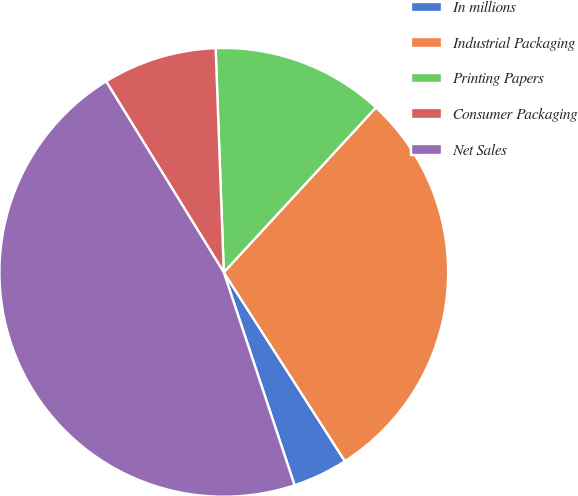<chart> <loc_0><loc_0><loc_500><loc_500><pie_chart><fcel>In millions<fcel>Industrial Packaging<fcel>Printing Papers<fcel>Consumer Packaging<fcel>Net Sales<nl><fcel>3.97%<fcel>29.06%<fcel>12.44%<fcel>8.21%<fcel>46.32%<nl></chart> 